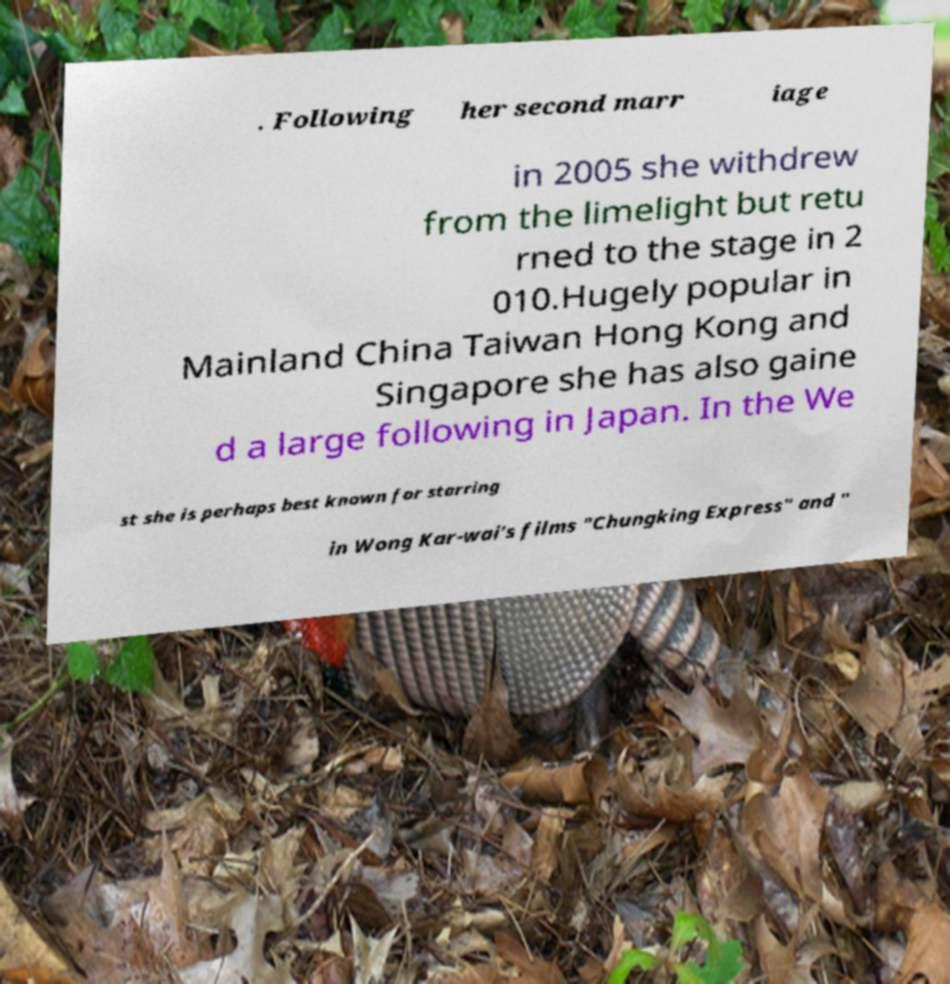Could you assist in decoding the text presented in this image and type it out clearly? . Following her second marr iage in 2005 she withdrew from the limelight but retu rned to the stage in 2 010.Hugely popular in Mainland China Taiwan Hong Kong and Singapore she has also gaine d a large following in Japan. In the We st she is perhaps best known for starring in Wong Kar-wai's films "Chungking Express" and " 